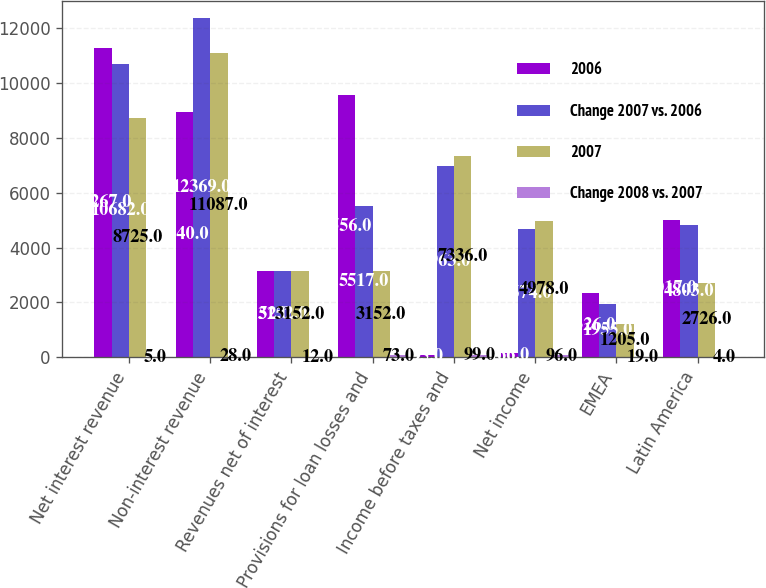Convert chart. <chart><loc_0><loc_0><loc_500><loc_500><stacked_bar_chart><ecel><fcel>Net interest revenue<fcel>Non-interest revenue<fcel>Revenues net of interest<fcel>Provisions for loan losses and<fcel>Income before taxes and<fcel>Net income<fcel>EMEA<fcel>Latin America<nl><fcel>2006<fcel>11267<fcel>8940<fcel>3152<fcel>9556<fcel>95<fcel>166<fcel>2326<fcel>5017<nl><fcel>Change 2007 vs. 2006<fcel>10682<fcel>12369<fcel>3152<fcel>5517<fcel>6963<fcel>4674<fcel>1955<fcel>4803<nl><fcel>2007<fcel>8725<fcel>11087<fcel>3152<fcel>3152<fcel>7336<fcel>4978<fcel>1205<fcel>2726<nl><fcel>Change 2008 vs. 2007<fcel>5<fcel>28<fcel>12<fcel>73<fcel>99<fcel>96<fcel>19<fcel>4<nl></chart> 